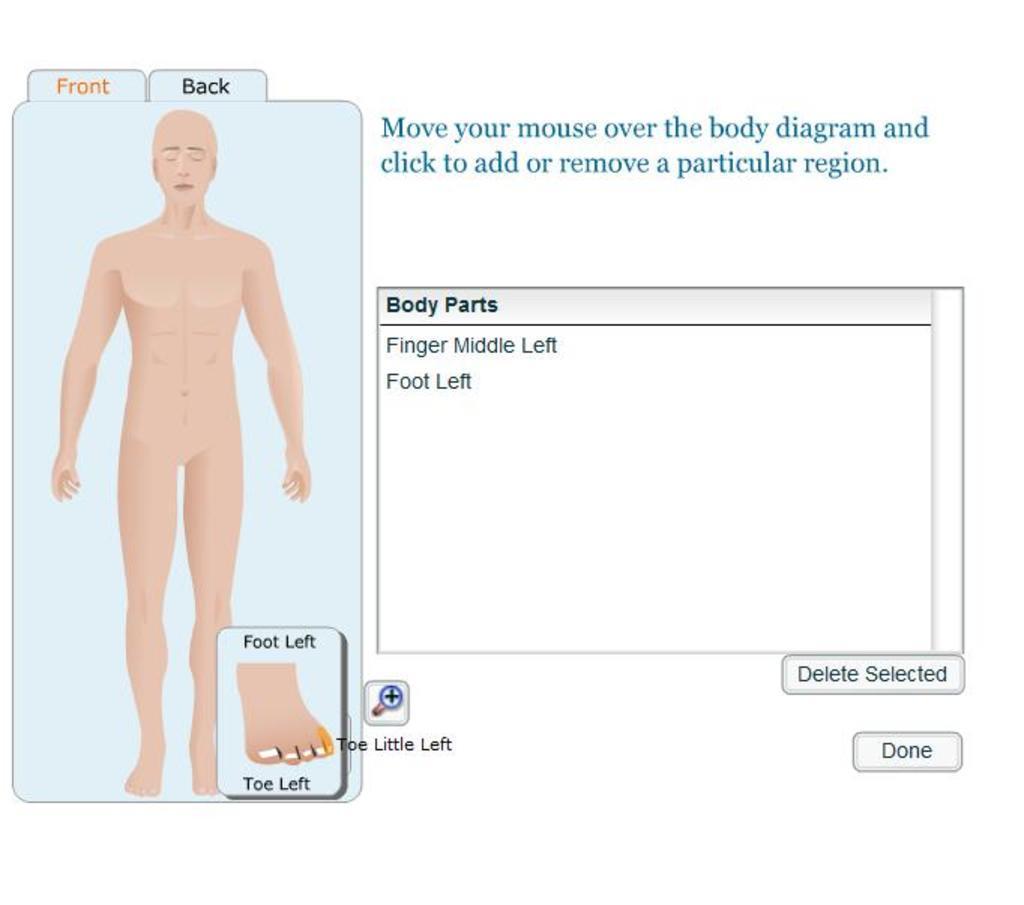Can you describe this image briefly? There is a picture of a human body on the left side of this image, and there is a text on the right side of this image. 